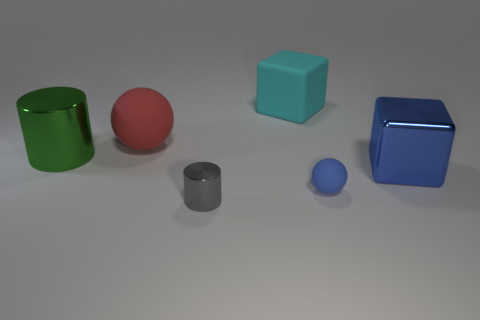If these objects were part of a child's toy block set, which might be easiest for them to stack? From the perspective of a child playing with toy blocks, the teal cube and the blue cube would likely be the easiest to stack due to their flat surfaces and stability. The cylinders and spheres might roll or move, making them more challenging to stack neatly. 